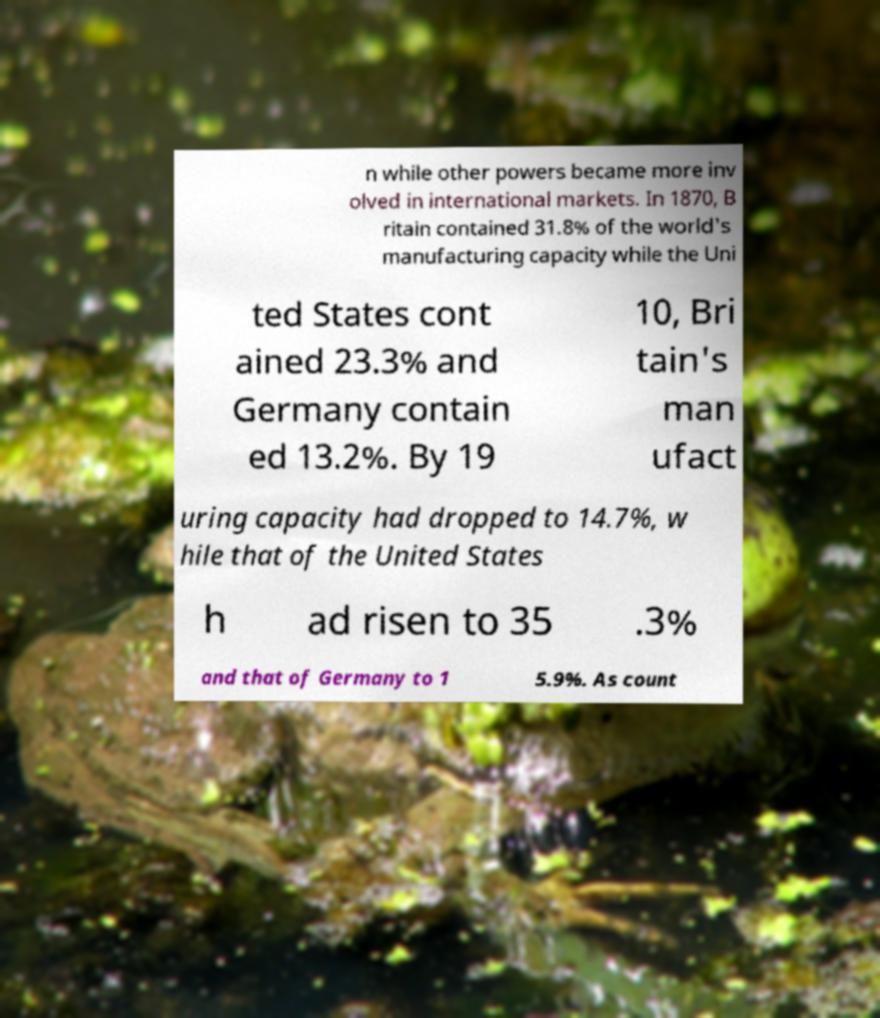What messages or text are displayed in this image? I need them in a readable, typed format. n while other powers became more inv olved in international markets. In 1870, B ritain contained 31.8% of the world's manufacturing capacity while the Uni ted States cont ained 23.3% and Germany contain ed 13.2%. By 19 10, Bri tain's man ufact uring capacity had dropped to 14.7%, w hile that of the United States h ad risen to 35 .3% and that of Germany to 1 5.9%. As count 